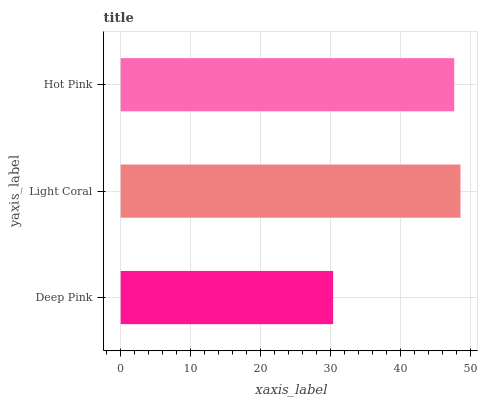Is Deep Pink the minimum?
Answer yes or no. Yes. Is Light Coral the maximum?
Answer yes or no. Yes. Is Hot Pink the minimum?
Answer yes or no. No. Is Hot Pink the maximum?
Answer yes or no. No. Is Light Coral greater than Hot Pink?
Answer yes or no. Yes. Is Hot Pink less than Light Coral?
Answer yes or no. Yes. Is Hot Pink greater than Light Coral?
Answer yes or no. No. Is Light Coral less than Hot Pink?
Answer yes or no. No. Is Hot Pink the high median?
Answer yes or no. Yes. Is Hot Pink the low median?
Answer yes or no. Yes. Is Light Coral the high median?
Answer yes or no. No. Is Light Coral the low median?
Answer yes or no. No. 